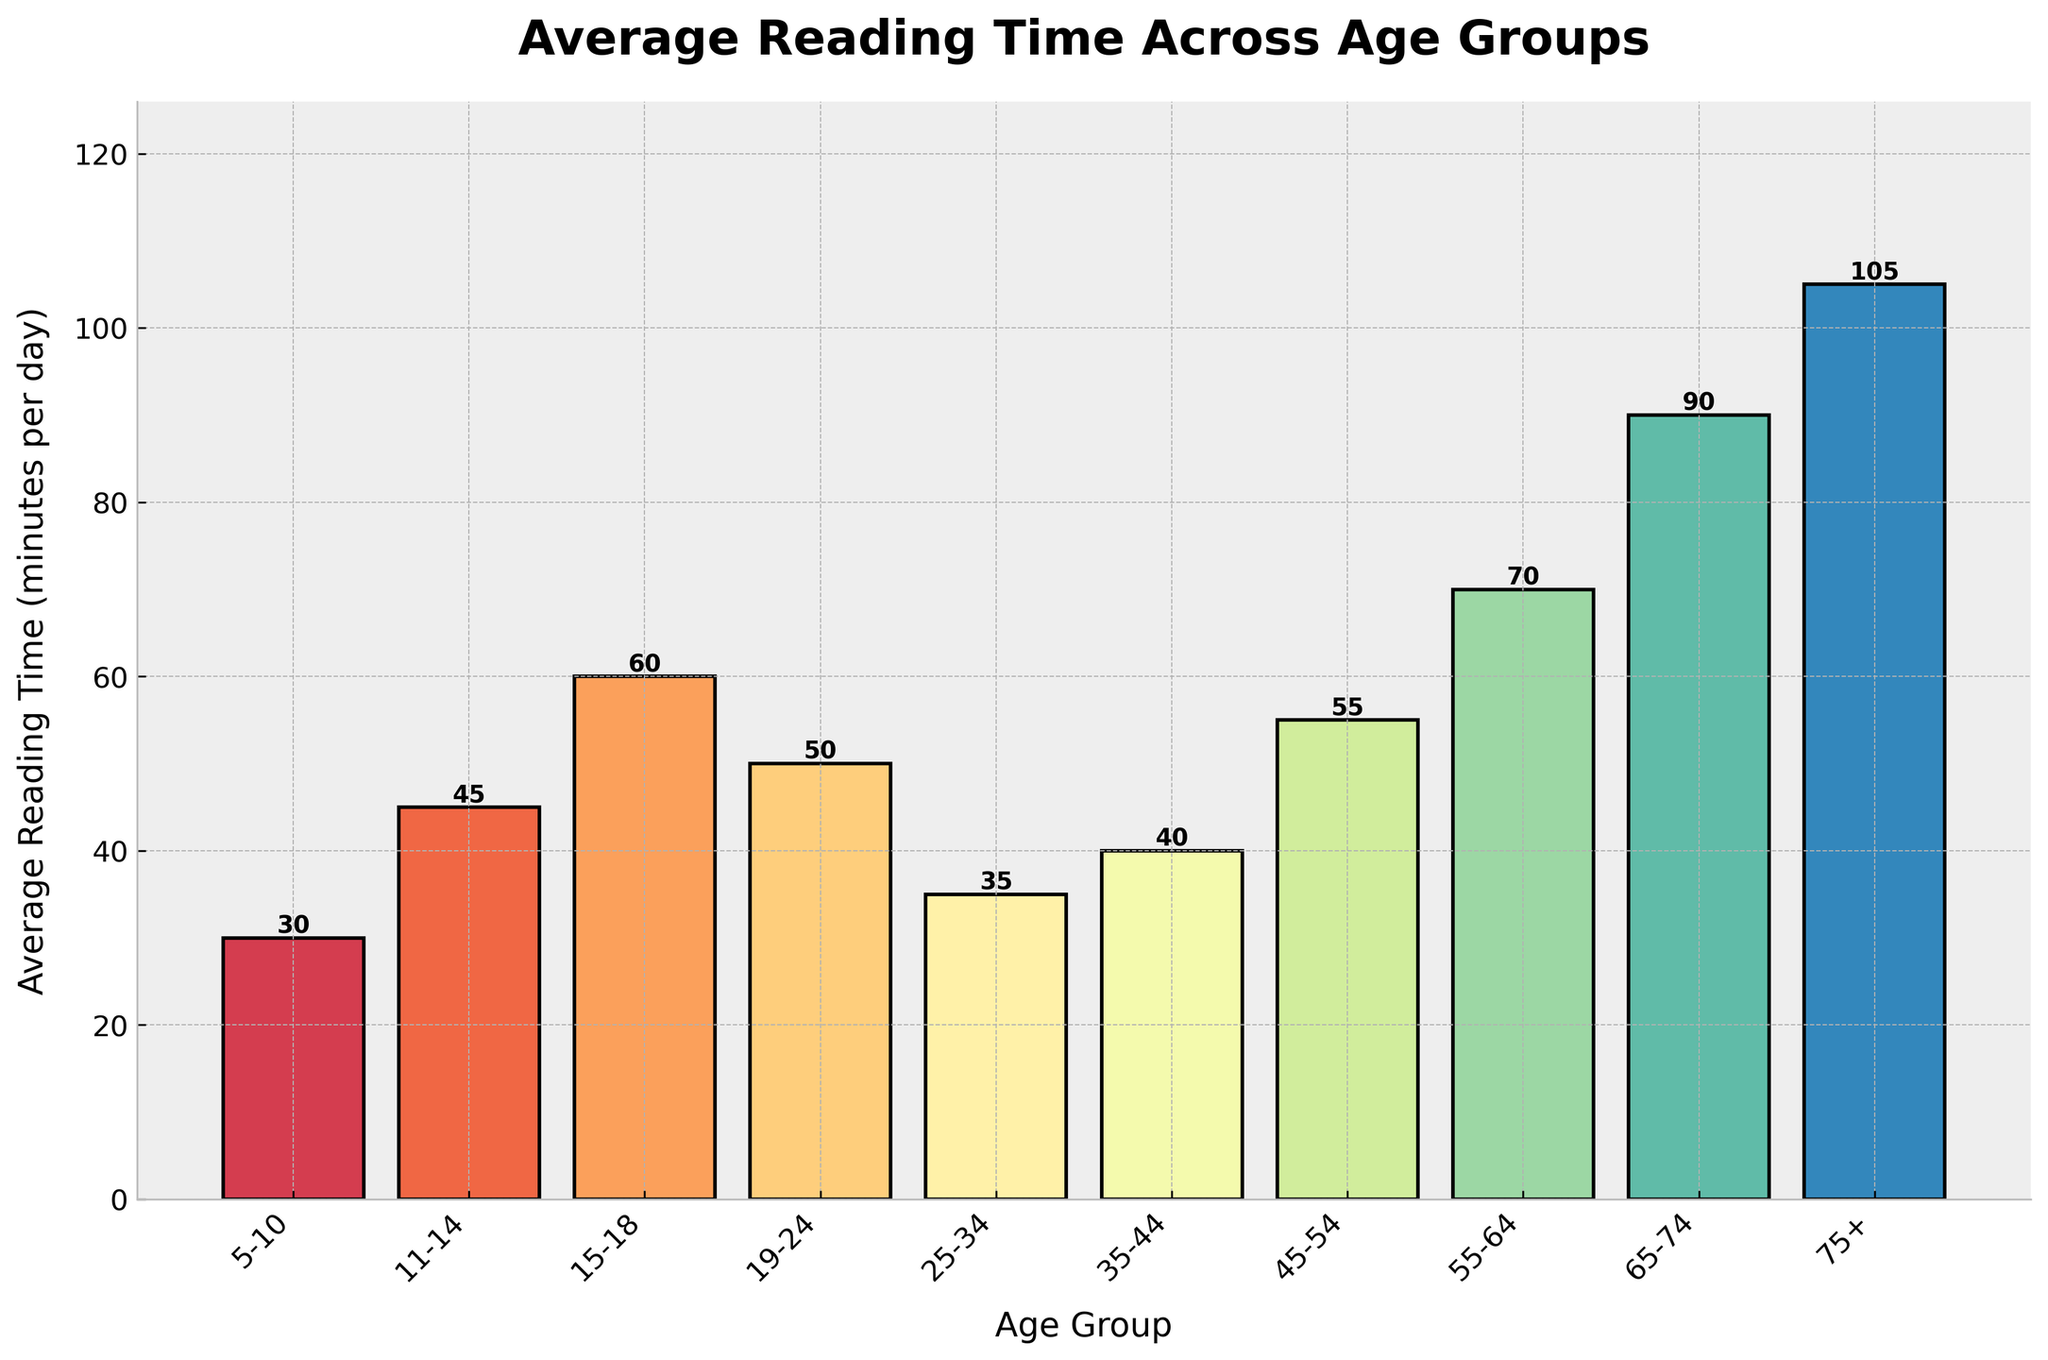What age group has the highest average reading time? By looking at the heights of the bars, the 75+ age group has the tallest bar, indicating the highest reading time.
Answer: 75+ Which age group has the lowest average reading time? By observing the shortest bar in the chart, the 5-10 age group has the lowest reading time.
Answer: 5-10 How much more time does the 75+ age group spend reading compared to the 5-10 age group? The 75+ age group's bar height is 105 minutes, and the 5-10 age group's bar height is 30 minutes. The difference is 105 - 30 = 75 minutes.
Answer: 75 minutes What is the average reading time for the 25-34 age group? The bar corresponding to the 25-34 age group shows an average reading time of 35 minutes.
Answer: 35 minutes What is the difference in reading time between the 15-18 and 19-24 age groups? The bar heights for the 15-18 and 19-24 age groups are 60 minutes and 50 minutes, respectively. The difference is 60 - 50 = 10 minutes.
Answer: 10 minutes Which age group reads more on average, 35-44 or 45-54? By comparing the heights of the bars, the 45-54 age group spends more time reading (55 minutes) than the 35-44 age group (40 minutes).
Answer: 45-54 Is there a trend in reading time as people get older? Older age groups tend to have taller bars, indicating that average reading time increases as age increases.
Answer: Yes What is the combined average reading time for age groups 55-64 and 65-74? The reading times are 70 minutes for the 55-64 group and 90 minutes for the 65-74 group. The combined total is 70 + 90 = 160 minutes.
Answer: 160 minutes Between which two consecutive age groups is the largest increase in reading time observed? By comparing the differences between consecutive age groups, the largest increase is between the 25-34 (35 minutes) and 35-44 (40 minutes) groups, which is an increase of 40 - 35 = 5 minutes.
Answer: 25-34 to 35-44 What is the average reading time of people aged 55 and above? We sum the reading times for 55-64 (70 mins), 65-74 (90 mins), and 75+ (105 mins) and find the average: (70 + 90 + 105) / 3 = 88.33 minutes.
Answer: 88.33 minutes 